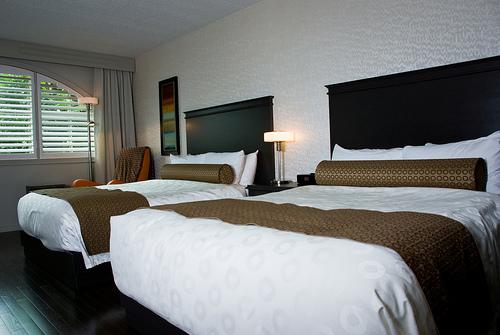Are the lights on?
Be succinct. Yes. How many beds are in the picture?
Concise answer only. 2. Is this a modern hotel room?
Write a very short answer. Yes. 